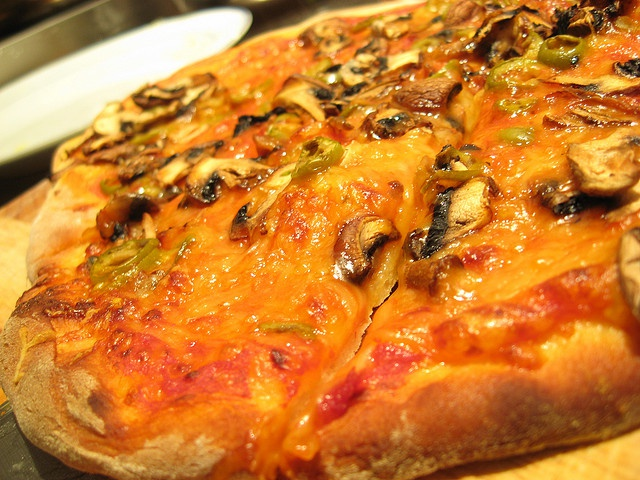Describe the objects in this image and their specific colors. I can see a pizza in orange, red, black, and brown tones in this image. 